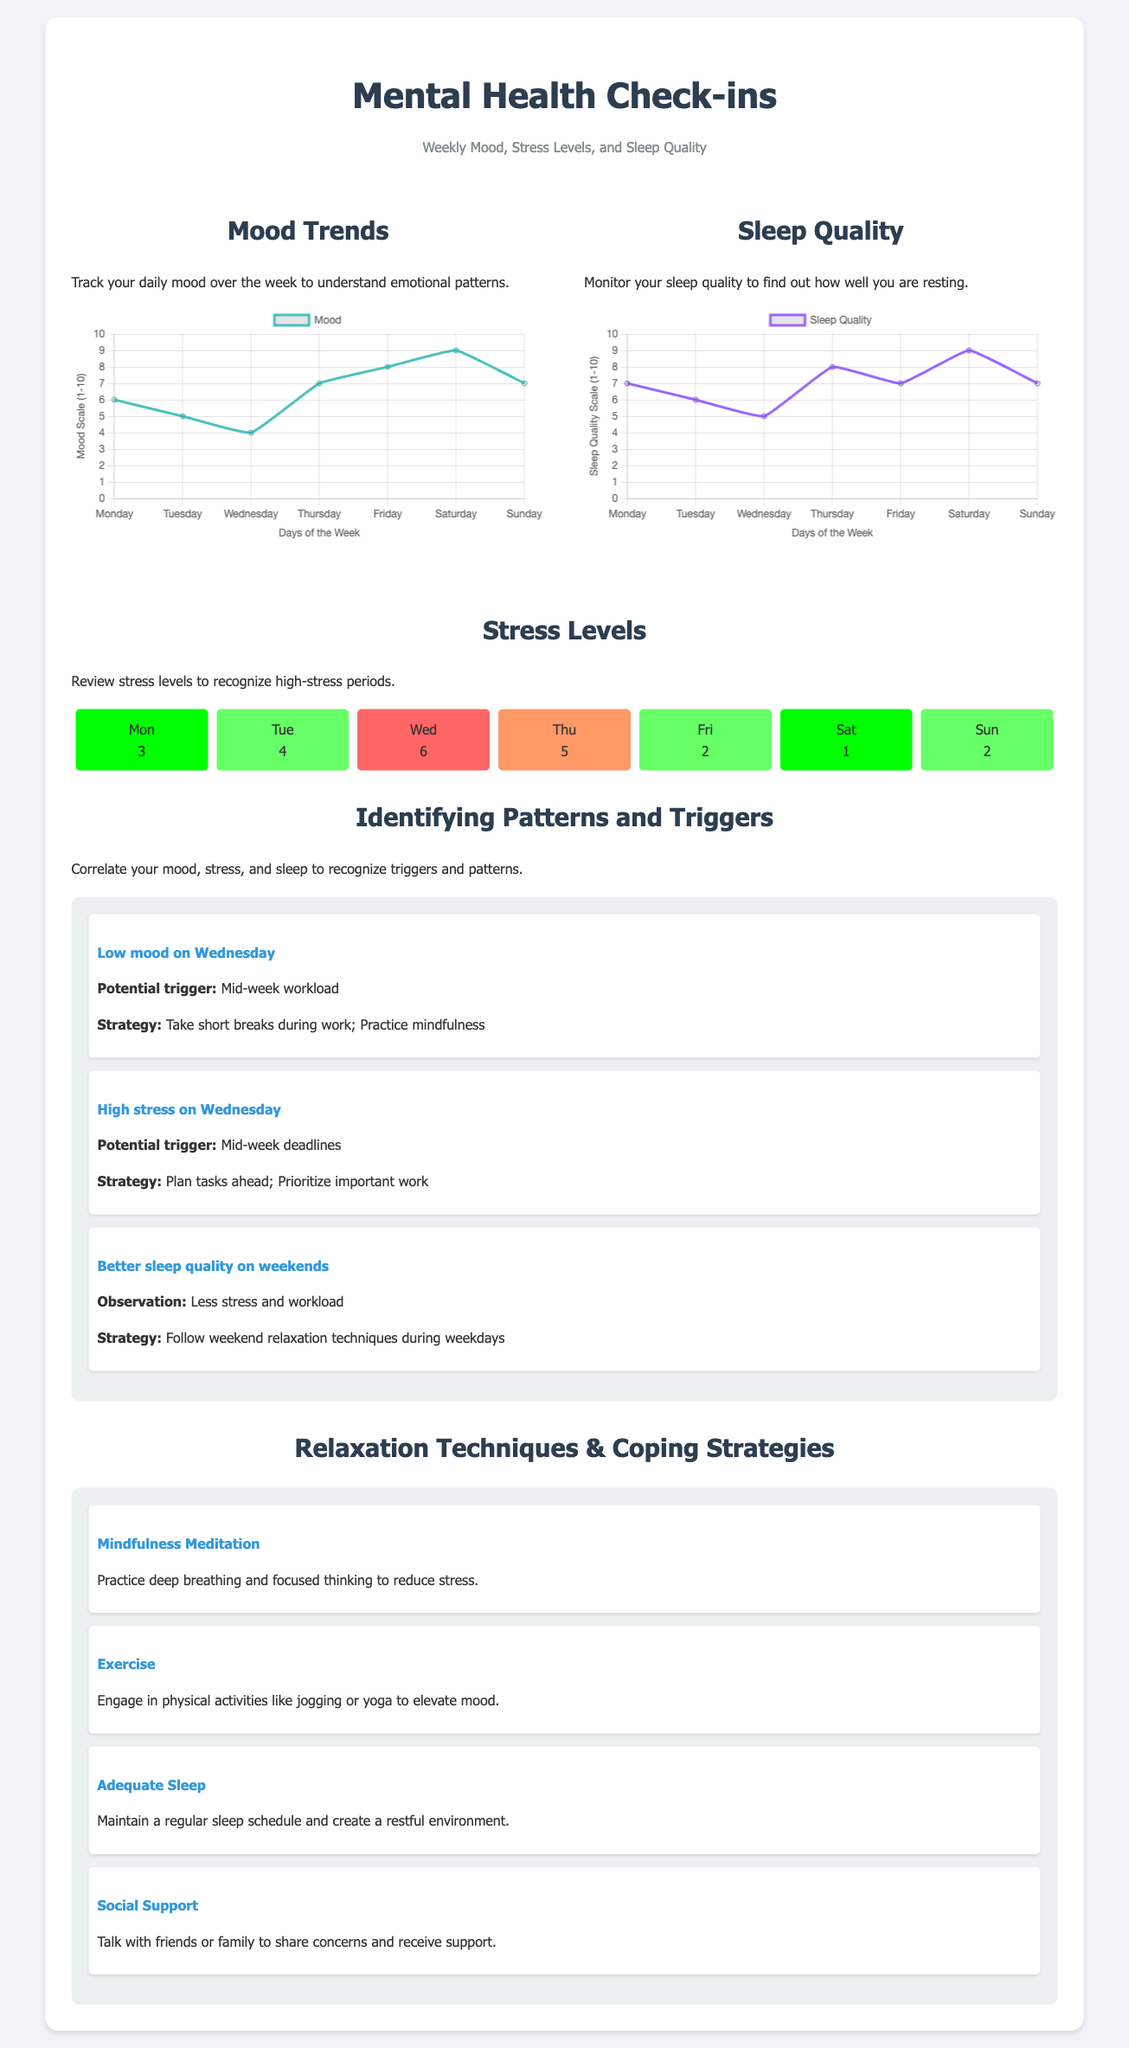what is the highest mood score recorded? The highest mood score recorded over the week is 9 on Saturday.
Answer: 9 what day had the lowest sleep quality score? The lowest sleep quality score recorded is 5 on Wednesday.
Answer: 5 which day has the highest stress level according to the heat map? The heat map indicates the highest stress level was on Wednesday with a score of 6.
Answer: 6 what is a suggested strategy for low mood on Wednesday? The suggested strategy for low mood on Wednesday is to take short breaks during work and practice mindfulness.
Answer: Take short breaks during work; Practice mindfulness how did sleep quality trend from Monday to Sunday? The sleep quality trend reveals a peak on Saturday, indicating better rest compared to the beginning of the week.
Answer: Peak on Saturday what is the typical pattern for stress levels during the week? The typical pattern shows mid-week experiencing higher stress levels, particularly on Wednesday.
Answer: Higher stress on Wednesday what relaxation technique suggests engaging in physical activities? The relaxation technique recommending physical activities is Exercise.
Answer: Exercise what is the mood level on Friday? The mood level recorded on Friday is 8.
Answer: 8 